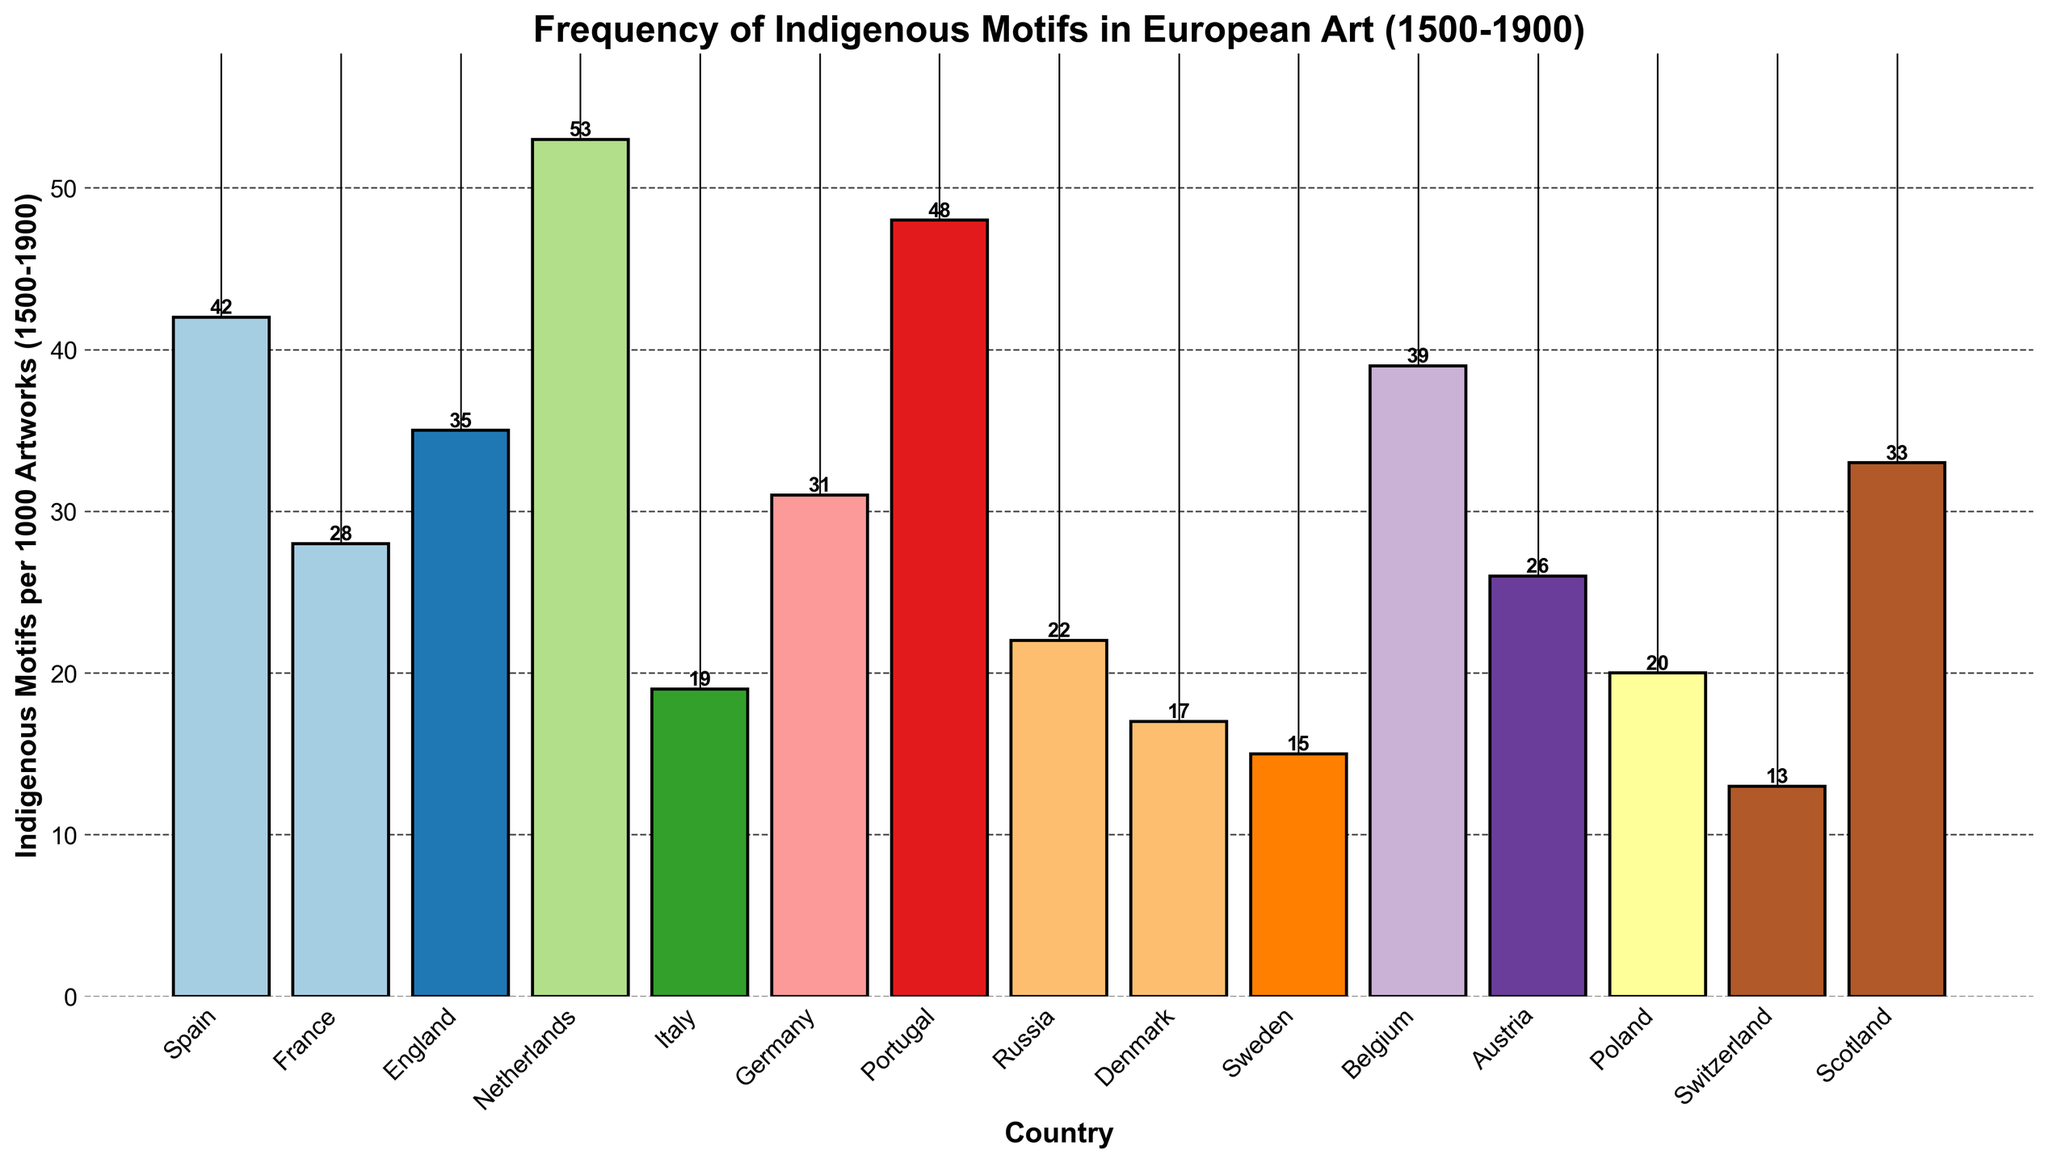Which country has the highest frequency of indigenous motifs in European art from 1500-1900? The bar for the Netherlands is the tallest among all countries, indicating the highest frequency.
Answer: Netherlands Which country shows the lowest frequency of indigenous motifs? The bar for Switzerland is the shortest, indicating the lowest frequency.
Answer: Switzerland How many countries have a frequency of indigenous motifs greater than 30 per 1000 artworks? Visual inspection shows that Spain, England, Netherlands, Germany, Portugal, Belgium, and Scotland have bars indicating frequencies greater than 30.
Answer: 7 Which two countries have nearly equal frequencies of indigenous motifs? The bars for France and Austria appear to be similar in height, indicating nearly equal frequencies (France: 28, Austria: 26).
Answer: France and Austria What is the difference in indigenous motif frequency between the country with the highest and the country with the lowest frequencies? The highest frequency is from the Netherlands (53) and the lowest is from Switzerland (13). The difference is 53 - 13.
Answer: 40 Is the frequency of indigenous motifs in German art greater than in Italian art? The height of the bar for Germany (31) is greater than the bar for Italy (19).
Answer: Yes What is the total frequency of indigenous motifs in the art of Spain and Portugal combined? The frequency for Spain is 42 and for Portugal is 48. Summing these values, 42 + 48 = 90.
Answer: 90 Which country has a frequency closest to 20 per 1000 artworks? The bar for Poland is closest to 20 with an actual value of 20.
Answer: Poland Are there more countries with frequencies less than 25 or more than 25? Visual inspection shows 8 countries with frequencies less than 25 (Italy, Russia, Denmark, Sweden, Austria, Poland, Switzerland, Scotland) and 7 countries with frequencies more than 25.
Answer: Less than 25 Which has a greater frequency of indigenous motifs, Belgium or Scotland? The height of the bar for Belgium (39) is greater than that for Scotland (33).
Answer: Belgium 